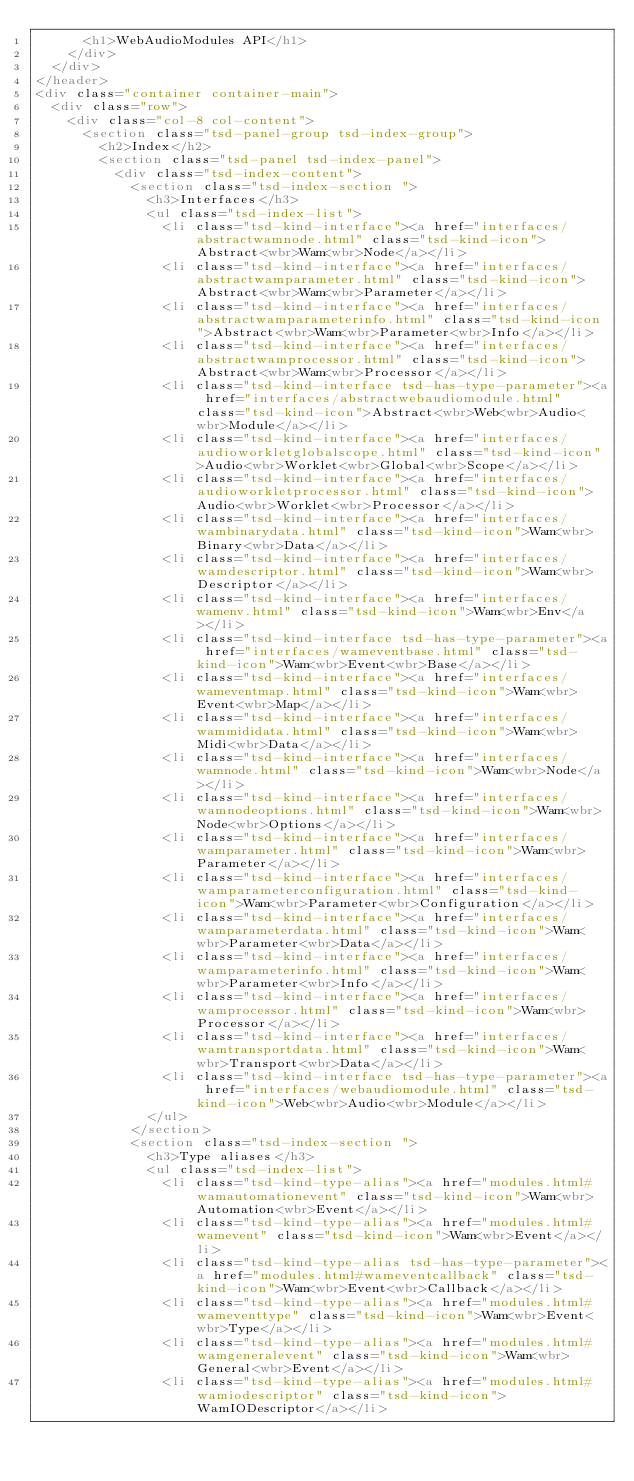Convert code to text. <code><loc_0><loc_0><loc_500><loc_500><_HTML_>			<h1>WebAudioModules API</h1>
		</div>
	</div>
</header>
<div class="container container-main">
	<div class="row">
		<div class="col-8 col-content">
			<section class="tsd-panel-group tsd-index-group">
				<h2>Index</h2>
				<section class="tsd-panel tsd-index-panel">
					<div class="tsd-index-content">
						<section class="tsd-index-section ">
							<h3>Interfaces</h3>
							<ul class="tsd-index-list">
								<li class="tsd-kind-interface"><a href="interfaces/abstractwamnode.html" class="tsd-kind-icon">Abstract<wbr>Wam<wbr>Node</a></li>
								<li class="tsd-kind-interface"><a href="interfaces/abstractwamparameter.html" class="tsd-kind-icon">Abstract<wbr>Wam<wbr>Parameter</a></li>
								<li class="tsd-kind-interface"><a href="interfaces/abstractwamparameterinfo.html" class="tsd-kind-icon">Abstract<wbr>Wam<wbr>Parameter<wbr>Info</a></li>
								<li class="tsd-kind-interface"><a href="interfaces/abstractwamprocessor.html" class="tsd-kind-icon">Abstract<wbr>Wam<wbr>Processor</a></li>
								<li class="tsd-kind-interface tsd-has-type-parameter"><a href="interfaces/abstractwebaudiomodule.html" class="tsd-kind-icon">Abstract<wbr>Web<wbr>Audio<wbr>Module</a></li>
								<li class="tsd-kind-interface"><a href="interfaces/audioworkletglobalscope.html" class="tsd-kind-icon">Audio<wbr>Worklet<wbr>Global<wbr>Scope</a></li>
								<li class="tsd-kind-interface"><a href="interfaces/audioworkletprocessor.html" class="tsd-kind-icon">Audio<wbr>Worklet<wbr>Processor</a></li>
								<li class="tsd-kind-interface"><a href="interfaces/wambinarydata.html" class="tsd-kind-icon">Wam<wbr>Binary<wbr>Data</a></li>
								<li class="tsd-kind-interface"><a href="interfaces/wamdescriptor.html" class="tsd-kind-icon">Wam<wbr>Descriptor</a></li>
								<li class="tsd-kind-interface"><a href="interfaces/wamenv.html" class="tsd-kind-icon">Wam<wbr>Env</a></li>
								<li class="tsd-kind-interface tsd-has-type-parameter"><a href="interfaces/wameventbase.html" class="tsd-kind-icon">Wam<wbr>Event<wbr>Base</a></li>
								<li class="tsd-kind-interface"><a href="interfaces/wameventmap.html" class="tsd-kind-icon">Wam<wbr>Event<wbr>Map</a></li>
								<li class="tsd-kind-interface"><a href="interfaces/wammididata.html" class="tsd-kind-icon">Wam<wbr>Midi<wbr>Data</a></li>
								<li class="tsd-kind-interface"><a href="interfaces/wamnode.html" class="tsd-kind-icon">Wam<wbr>Node</a></li>
								<li class="tsd-kind-interface"><a href="interfaces/wamnodeoptions.html" class="tsd-kind-icon">Wam<wbr>Node<wbr>Options</a></li>
								<li class="tsd-kind-interface"><a href="interfaces/wamparameter.html" class="tsd-kind-icon">Wam<wbr>Parameter</a></li>
								<li class="tsd-kind-interface"><a href="interfaces/wamparameterconfiguration.html" class="tsd-kind-icon">Wam<wbr>Parameter<wbr>Configuration</a></li>
								<li class="tsd-kind-interface"><a href="interfaces/wamparameterdata.html" class="tsd-kind-icon">Wam<wbr>Parameter<wbr>Data</a></li>
								<li class="tsd-kind-interface"><a href="interfaces/wamparameterinfo.html" class="tsd-kind-icon">Wam<wbr>Parameter<wbr>Info</a></li>
								<li class="tsd-kind-interface"><a href="interfaces/wamprocessor.html" class="tsd-kind-icon">Wam<wbr>Processor</a></li>
								<li class="tsd-kind-interface"><a href="interfaces/wamtransportdata.html" class="tsd-kind-icon">Wam<wbr>Transport<wbr>Data</a></li>
								<li class="tsd-kind-interface tsd-has-type-parameter"><a href="interfaces/webaudiomodule.html" class="tsd-kind-icon">Web<wbr>Audio<wbr>Module</a></li>
							</ul>
						</section>
						<section class="tsd-index-section ">
							<h3>Type aliases</h3>
							<ul class="tsd-index-list">
								<li class="tsd-kind-type-alias"><a href="modules.html#wamautomationevent" class="tsd-kind-icon">Wam<wbr>Automation<wbr>Event</a></li>
								<li class="tsd-kind-type-alias"><a href="modules.html#wamevent" class="tsd-kind-icon">Wam<wbr>Event</a></li>
								<li class="tsd-kind-type-alias tsd-has-type-parameter"><a href="modules.html#wameventcallback" class="tsd-kind-icon">Wam<wbr>Event<wbr>Callback</a></li>
								<li class="tsd-kind-type-alias"><a href="modules.html#wameventtype" class="tsd-kind-icon">Wam<wbr>Event<wbr>Type</a></li>
								<li class="tsd-kind-type-alias"><a href="modules.html#wamgeneralevent" class="tsd-kind-icon">Wam<wbr>General<wbr>Event</a></li>
								<li class="tsd-kind-type-alias"><a href="modules.html#wamiodescriptor" class="tsd-kind-icon">WamIODescriptor</a></li></code> 